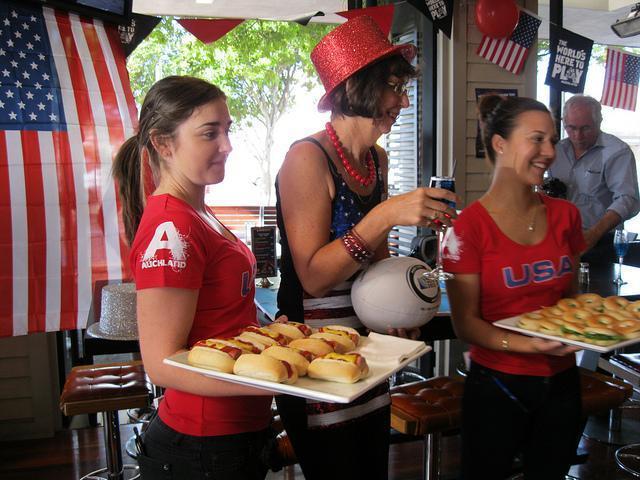How many people are there?
Give a very brief answer. 5. How many chairs can be seen?
Give a very brief answer. 3. How many pizza is there?
Give a very brief answer. 0. 